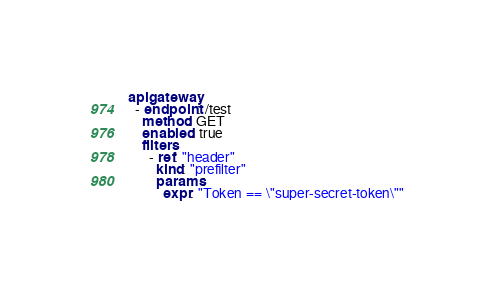Convert code to text. <code><loc_0><loc_0><loc_500><loc_500><_YAML_>apigateway:
  - endpoint: /test
    method: GET
    enabled: true
    filters:
      - ref: "header"
        kind: "prefilter"
        params:
          expr: "Token == \"super-secret-token\""
</code> 